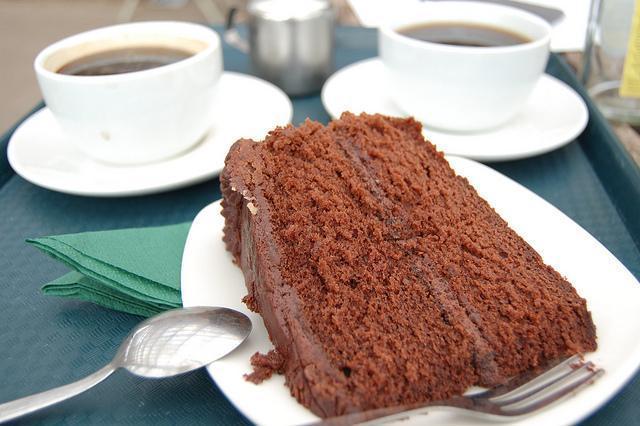How many cups are there?
Give a very brief answer. 2. How many cups can you see?
Give a very brief answer. 2. 